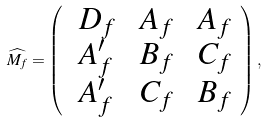<formula> <loc_0><loc_0><loc_500><loc_500>\widehat { M _ { f } } = \left ( \begin{array} { l l l } \ D _ { f } & \ A _ { f } & \ A _ { f } \\ \ A ^ { \prime } _ { f } & \ B _ { f } & \ C _ { f } \\ \ A ^ { \prime } _ { f } & \ C _ { f } & \ B _ { f } \\ \end{array} \right ) , \</formula> 